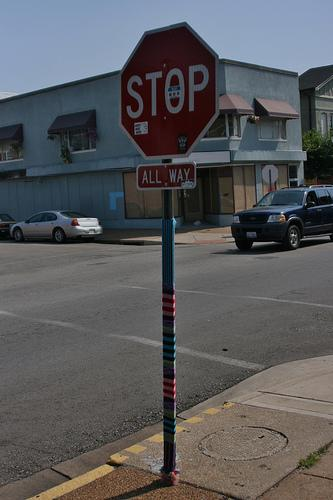Question: why is there a shadow?
Choices:
A. Lamp.
B. Flame.
C. Light.
D. Radiation.
Answer with the letter. Answer: C Question: where is this scene?
Choices:
A. By the fence.
B. By the building.
C. Near the corner by the stop sign.
D. On the porch.
Answer with the letter. Answer: C Question: how is the sign?
Choices:
A. Dirty.
B. Illegiible.
C. Clear.
D. New.
Answer with the letter. Answer: C Question: what does this sign say?
Choices:
A. Stop.
B. Yield.
C. No Left Turn.
D. Railroad Crossing.
Answer with the letter. Answer: A Question: when is this?
Choices:
A. Daytime.
B. Summer.
C. Midnight.
D. Sunrise.
Answer with the letter. Answer: A Question: who is present?
Choices:
A. A family.
B. Three judges.
C. No one.
D. A man.
Answer with the letter. Answer: C 